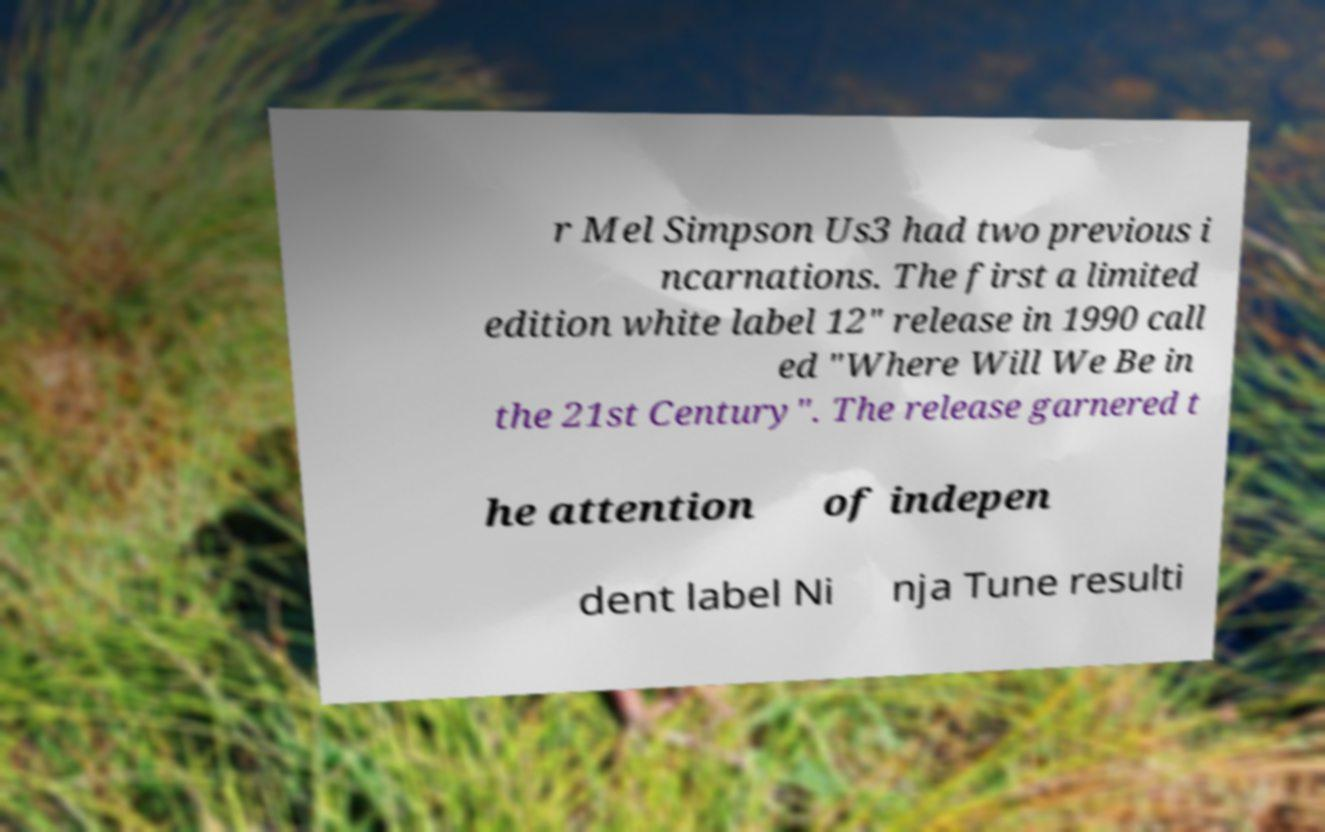There's text embedded in this image that I need extracted. Can you transcribe it verbatim? r Mel Simpson Us3 had two previous i ncarnations. The first a limited edition white label 12" release in 1990 call ed "Where Will We Be in the 21st Century". The release garnered t he attention of indepen dent label Ni nja Tune resulti 